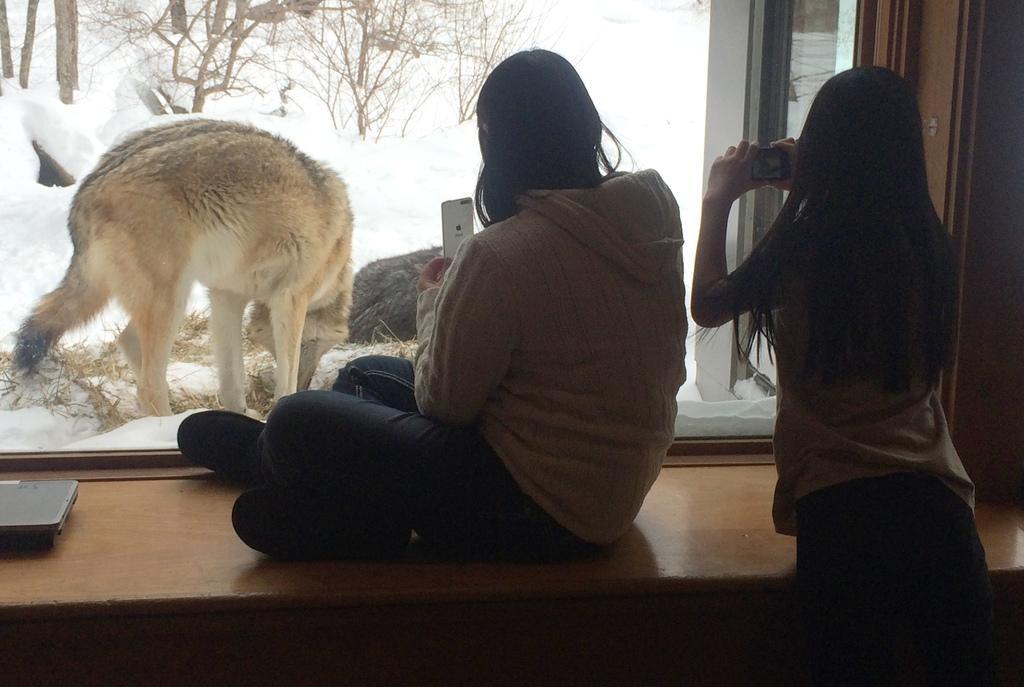Can you describe this image briefly? In this image, we can see two persons. Here a woman is holding a camera and other woman holding a mobile. Here we can see woman is sitting on the wooden table. Background we can see glass window. Through the glass we can see an animal, snow and plants. On the left side of the image, we can see an object on the wooden table. 